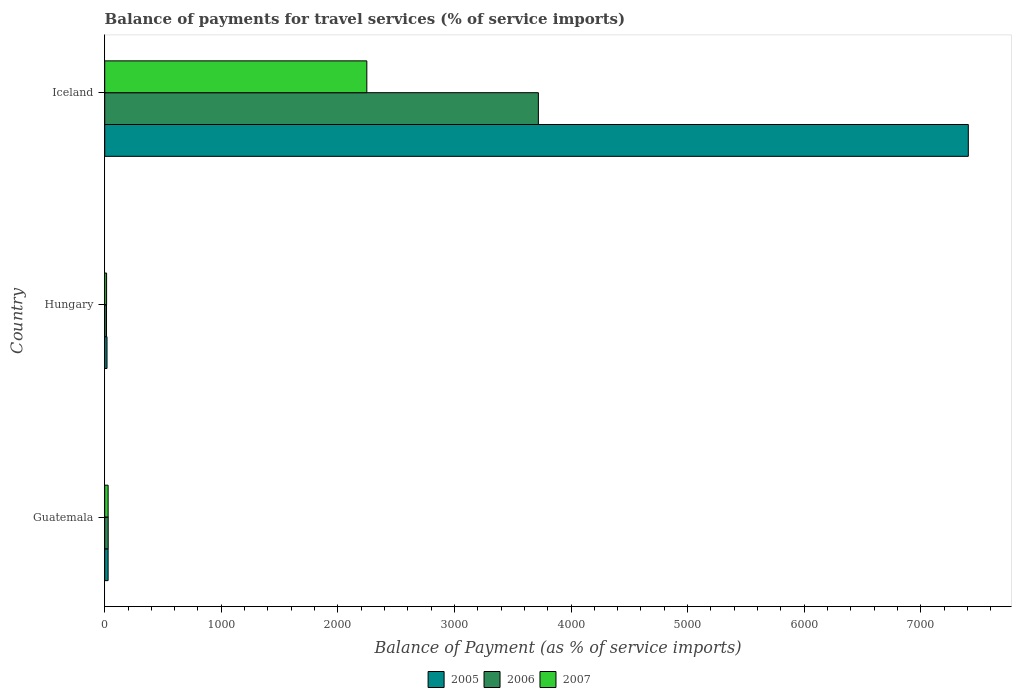How many groups of bars are there?
Provide a short and direct response. 3. How many bars are there on the 1st tick from the top?
Ensure brevity in your answer.  3. How many bars are there on the 1st tick from the bottom?
Offer a very short reply. 3. What is the label of the 1st group of bars from the top?
Offer a terse response. Iceland. What is the balance of payments for travel services in 2007 in Guatemala?
Provide a short and direct response. 29.26. Across all countries, what is the maximum balance of payments for travel services in 2007?
Keep it short and to the point. 2248.42. Across all countries, what is the minimum balance of payments for travel services in 2007?
Provide a succinct answer. 16.08. In which country was the balance of payments for travel services in 2005 maximum?
Offer a terse response. Iceland. In which country was the balance of payments for travel services in 2007 minimum?
Ensure brevity in your answer.  Hungary. What is the total balance of payments for travel services in 2006 in the graph?
Your answer should be very brief. 3765.23. What is the difference between the balance of payments for travel services in 2005 in Guatemala and that in Hungary?
Make the answer very short. 9.29. What is the difference between the balance of payments for travel services in 2005 in Guatemala and the balance of payments for travel services in 2006 in Iceland?
Your response must be concise. -3691.01. What is the average balance of payments for travel services in 2006 per country?
Your answer should be compact. 1255.08. What is the difference between the balance of payments for travel services in 2006 and balance of payments for travel services in 2007 in Guatemala?
Make the answer very short. 0.46. What is the ratio of the balance of payments for travel services in 2006 in Guatemala to that in Iceland?
Offer a terse response. 0.01. Is the balance of payments for travel services in 2006 in Hungary less than that in Iceland?
Ensure brevity in your answer.  Yes. What is the difference between the highest and the second highest balance of payments for travel services in 2006?
Offer a terse response. 3690.32. What is the difference between the highest and the lowest balance of payments for travel services in 2006?
Your response must be concise. 3704.57. What does the 2nd bar from the bottom in Guatemala represents?
Ensure brevity in your answer.  2006. Is it the case that in every country, the sum of the balance of payments for travel services in 2005 and balance of payments for travel services in 2007 is greater than the balance of payments for travel services in 2006?
Your response must be concise. Yes. Are all the bars in the graph horizontal?
Provide a succinct answer. Yes. How many countries are there in the graph?
Your response must be concise. 3. What is the difference between two consecutive major ticks on the X-axis?
Ensure brevity in your answer.  1000. Where does the legend appear in the graph?
Ensure brevity in your answer.  Bottom center. What is the title of the graph?
Provide a short and direct response. Balance of payments for travel services (% of service imports). What is the label or title of the X-axis?
Keep it short and to the point. Balance of Payment (as % of service imports). What is the label or title of the Y-axis?
Offer a terse response. Country. What is the Balance of Payment (as % of service imports) of 2005 in Guatemala?
Offer a very short reply. 29.03. What is the Balance of Payment (as % of service imports) in 2006 in Guatemala?
Ensure brevity in your answer.  29.72. What is the Balance of Payment (as % of service imports) of 2007 in Guatemala?
Ensure brevity in your answer.  29.26. What is the Balance of Payment (as % of service imports) in 2005 in Hungary?
Your answer should be compact. 19.74. What is the Balance of Payment (as % of service imports) of 2006 in Hungary?
Make the answer very short. 15.47. What is the Balance of Payment (as % of service imports) of 2007 in Hungary?
Your answer should be very brief. 16.08. What is the Balance of Payment (as % of service imports) of 2005 in Iceland?
Provide a succinct answer. 7408.18. What is the Balance of Payment (as % of service imports) of 2006 in Iceland?
Make the answer very short. 3720.04. What is the Balance of Payment (as % of service imports) of 2007 in Iceland?
Offer a terse response. 2248.42. Across all countries, what is the maximum Balance of Payment (as % of service imports) in 2005?
Your response must be concise. 7408.18. Across all countries, what is the maximum Balance of Payment (as % of service imports) of 2006?
Your answer should be very brief. 3720.04. Across all countries, what is the maximum Balance of Payment (as % of service imports) of 2007?
Give a very brief answer. 2248.42. Across all countries, what is the minimum Balance of Payment (as % of service imports) of 2005?
Make the answer very short. 19.74. Across all countries, what is the minimum Balance of Payment (as % of service imports) in 2006?
Offer a terse response. 15.47. Across all countries, what is the minimum Balance of Payment (as % of service imports) of 2007?
Provide a succinct answer. 16.08. What is the total Balance of Payment (as % of service imports) of 2005 in the graph?
Your answer should be compact. 7456.95. What is the total Balance of Payment (as % of service imports) of 2006 in the graph?
Ensure brevity in your answer.  3765.23. What is the total Balance of Payment (as % of service imports) of 2007 in the graph?
Offer a very short reply. 2293.76. What is the difference between the Balance of Payment (as % of service imports) in 2005 in Guatemala and that in Hungary?
Ensure brevity in your answer.  9.29. What is the difference between the Balance of Payment (as % of service imports) in 2006 in Guatemala and that in Hungary?
Offer a terse response. 14.24. What is the difference between the Balance of Payment (as % of service imports) of 2007 in Guatemala and that in Hungary?
Make the answer very short. 13.18. What is the difference between the Balance of Payment (as % of service imports) in 2005 in Guatemala and that in Iceland?
Make the answer very short. -7379.15. What is the difference between the Balance of Payment (as % of service imports) in 2006 in Guatemala and that in Iceland?
Give a very brief answer. -3690.32. What is the difference between the Balance of Payment (as % of service imports) in 2007 in Guatemala and that in Iceland?
Offer a very short reply. -2219.17. What is the difference between the Balance of Payment (as % of service imports) of 2005 in Hungary and that in Iceland?
Ensure brevity in your answer.  -7388.44. What is the difference between the Balance of Payment (as % of service imports) of 2006 in Hungary and that in Iceland?
Keep it short and to the point. -3704.57. What is the difference between the Balance of Payment (as % of service imports) of 2007 in Hungary and that in Iceland?
Make the answer very short. -2232.34. What is the difference between the Balance of Payment (as % of service imports) in 2005 in Guatemala and the Balance of Payment (as % of service imports) in 2006 in Hungary?
Your response must be concise. 13.55. What is the difference between the Balance of Payment (as % of service imports) of 2005 in Guatemala and the Balance of Payment (as % of service imports) of 2007 in Hungary?
Give a very brief answer. 12.95. What is the difference between the Balance of Payment (as % of service imports) of 2006 in Guatemala and the Balance of Payment (as % of service imports) of 2007 in Hungary?
Your answer should be compact. 13.64. What is the difference between the Balance of Payment (as % of service imports) in 2005 in Guatemala and the Balance of Payment (as % of service imports) in 2006 in Iceland?
Keep it short and to the point. -3691.01. What is the difference between the Balance of Payment (as % of service imports) of 2005 in Guatemala and the Balance of Payment (as % of service imports) of 2007 in Iceland?
Keep it short and to the point. -2219.39. What is the difference between the Balance of Payment (as % of service imports) of 2006 in Guatemala and the Balance of Payment (as % of service imports) of 2007 in Iceland?
Give a very brief answer. -2218.71. What is the difference between the Balance of Payment (as % of service imports) of 2005 in Hungary and the Balance of Payment (as % of service imports) of 2006 in Iceland?
Give a very brief answer. -3700.3. What is the difference between the Balance of Payment (as % of service imports) in 2005 in Hungary and the Balance of Payment (as % of service imports) in 2007 in Iceland?
Make the answer very short. -2228.68. What is the difference between the Balance of Payment (as % of service imports) of 2006 in Hungary and the Balance of Payment (as % of service imports) of 2007 in Iceland?
Keep it short and to the point. -2232.95. What is the average Balance of Payment (as % of service imports) in 2005 per country?
Your answer should be compact. 2485.65. What is the average Balance of Payment (as % of service imports) in 2006 per country?
Ensure brevity in your answer.  1255.08. What is the average Balance of Payment (as % of service imports) of 2007 per country?
Your response must be concise. 764.59. What is the difference between the Balance of Payment (as % of service imports) in 2005 and Balance of Payment (as % of service imports) in 2006 in Guatemala?
Offer a terse response. -0.69. What is the difference between the Balance of Payment (as % of service imports) in 2005 and Balance of Payment (as % of service imports) in 2007 in Guatemala?
Your answer should be very brief. -0.23. What is the difference between the Balance of Payment (as % of service imports) of 2006 and Balance of Payment (as % of service imports) of 2007 in Guatemala?
Provide a short and direct response. 0.46. What is the difference between the Balance of Payment (as % of service imports) of 2005 and Balance of Payment (as % of service imports) of 2006 in Hungary?
Your answer should be compact. 4.27. What is the difference between the Balance of Payment (as % of service imports) in 2005 and Balance of Payment (as % of service imports) in 2007 in Hungary?
Your response must be concise. 3.66. What is the difference between the Balance of Payment (as % of service imports) in 2006 and Balance of Payment (as % of service imports) in 2007 in Hungary?
Provide a succinct answer. -0.61. What is the difference between the Balance of Payment (as % of service imports) in 2005 and Balance of Payment (as % of service imports) in 2006 in Iceland?
Provide a succinct answer. 3688.14. What is the difference between the Balance of Payment (as % of service imports) of 2005 and Balance of Payment (as % of service imports) of 2007 in Iceland?
Offer a very short reply. 5159.76. What is the difference between the Balance of Payment (as % of service imports) in 2006 and Balance of Payment (as % of service imports) in 2007 in Iceland?
Keep it short and to the point. 1471.62. What is the ratio of the Balance of Payment (as % of service imports) of 2005 in Guatemala to that in Hungary?
Give a very brief answer. 1.47. What is the ratio of the Balance of Payment (as % of service imports) in 2006 in Guatemala to that in Hungary?
Offer a terse response. 1.92. What is the ratio of the Balance of Payment (as % of service imports) in 2007 in Guatemala to that in Hungary?
Keep it short and to the point. 1.82. What is the ratio of the Balance of Payment (as % of service imports) in 2005 in Guatemala to that in Iceland?
Make the answer very short. 0. What is the ratio of the Balance of Payment (as % of service imports) of 2006 in Guatemala to that in Iceland?
Provide a succinct answer. 0.01. What is the ratio of the Balance of Payment (as % of service imports) in 2007 in Guatemala to that in Iceland?
Make the answer very short. 0.01. What is the ratio of the Balance of Payment (as % of service imports) in 2005 in Hungary to that in Iceland?
Your answer should be very brief. 0. What is the ratio of the Balance of Payment (as % of service imports) in 2006 in Hungary to that in Iceland?
Keep it short and to the point. 0. What is the ratio of the Balance of Payment (as % of service imports) of 2007 in Hungary to that in Iceland?
Ensure brevity in your answer.  0.01. What is the difference between the highest and the second highest Balance of Payment (as % of service imports) of 2005?
Your answer should be very brief. 7379.15. What is the difference between the highest and the second highest Balance of Payment (as % of service imports) of 2006?
Your response must be concise. 3690.32. What is the difference between the highest and the second highest Balance of Payment (as % of service imports) in 2007?
Keep it short and to the point. 2219.17. What is the difference between the highest and the lowest Balance of Payment (as % of service imports) of 2005?
Offer a terse response. 7388.44. What is the difference between the highest and the lowest Balance of Payment (as % of service imports) in 2006?
Provide a succinct answer. 3704.57. What is the difference between the highest and the lowest Balance of Payment (as % of service imports) of 2007?
Keep it short and to the point. 2232.34. 